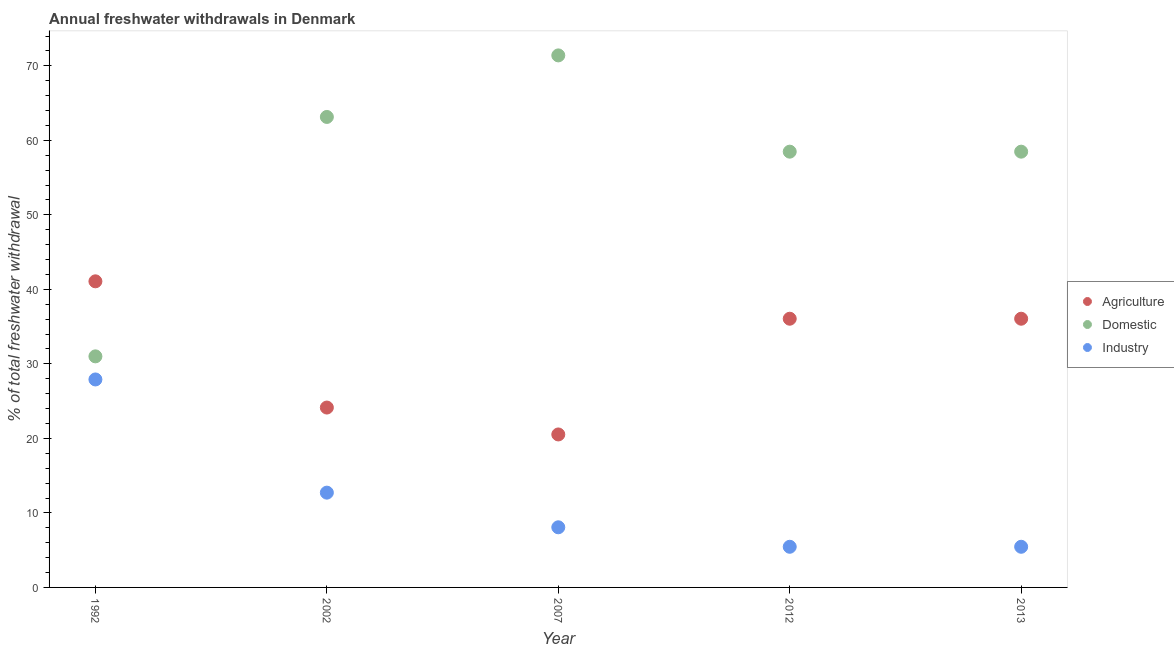What is the percentage of freshwater withdrawal for industry in 1992?
Your answer should be compact. 27.91. Across all years, what is the maximum percentage of freshwater withdrawal for domestic purposes?
Ensure brevity in your answer.  71.4. Across all years, what is the minimum percentage of freshwater withdrawal for domestic purposes?
Provide a short and direct response. 31.01. In which year was the percentage of freshwater withdrawal for agriculture maximum?
Your response must be concise. 1992. In which year was the percentage of freshwater withdrawal for industry minimum?
Ensure brevity in your answer.  2012. What is the total percentage of freshwater withdrawal for industry in the graph?
Provide a short and direct response. 59.61. What is the difference between the percentage of freshwater withdrawal for agriculture in 2002 and that in 2012?
Your answer should be compact. -11.92. What is the difference between the percentage of freshwater withdrawal for domestic purposes in 2007 and the percentage of freshwater withdrawal for agriculture in 2002?
Provide a short and direct response. 47.26. What is the average percentage of freshwater withdrawal for domestic purposes per year?
Your response must be concise. 56.5. In the year 2013, what is the difference between the percentage of freshwater withdrawal for domestic purposes and percentage of freshwater withdrawal for industry?
Keep it short and to the point. 53.02. What is the ratio of the percentage of freshwater withdrawal for agriculture in 1992 to that in 2012?
Give a very brief answer. 1.14. Is the percentage of freshwater withdrawal for industry in 2012 less than that in 2013?
Keep it short and to the point. No. Is the difference between the percentage of freshwater withdrawal for industry in 1992 and 2002 greater than the difference between the percentage of freshwater withdrawal for domestic purposes in 1992 and 2002?
Your response must be concise. Yes. What is the difference between the highest and the second highest percentage of freshwater withdrawal for agriculture?
Make the answer very short. 5.02. What is the difference between the highest and the lowest percentage of freshwater withdrawal for industry?
Your response must be concise. 22.45. Is it the case that in every year, the sum of the percentage of freshwater withdrawal for agriculture and percentage of freshwater withdrawal for domestic purposes is greater than the percentage of freshwater withdrawal for industry?
Make the answer very short. Yes. Is the percentage of freshwater withdrawal for industry strictly less than the percentage of freshwater withdrawal for domestic purposes over the years?
Ensure brevity in your answer.  Yes. How many dotlines are there?
Your response must be concise. 3. Does the graph contain any zero values?
Offer a very short reply. No. Does the graph contain grids?
Give a very brief answer. No. What is the title of the graph?
Your response must be concise. Annual freshwater withdrawals in Denmark. Does "Maunufacturing" appear as one of the legend labels in the graph?
Provide a short and direct response. No. What is the label or title of the Y-axis?
Give a very brief answer. % of total freshwater withdrawal. What is the % of total freshwater withdrawal in Agriculture in 1992?
Provide a succinct answer. 41.08. What is the % of total freshwater withdrawal of Domestic in 1992?
Give a very brief answer. 31.01. What is the % of total freshwater withdrawal of Industry in 1992?
Keep it short and to the point. 27.91. What is the % of total freshwater withdrawal in Agriculture in 2002?
Your answer should be compact. 24.14. What is the % of total freshwater withdrawal of Domestic in 2002?
Provide a short and direct response. 63.14. What is the % of total freshwater withdrawal in Industry in 2002?
Offer a terse response. 12.72. What is the % of total freshwater withdrawal of Agriculture in 2007?
Your answer should be very brief. 20.53. What is the % of total freshwater withdrawal in Domestic in 2007?
Your answer should be compact. 71.4. What is the % of total freshwater withdrawal in Industry in 2007?
Provide a succinct answer. 8.07. What is the % of total freshwater withdrawal in Agriculture in 2012?
Keep it short and to the point. 36.06. What is the % of total freshwater withdrawal in Domestic in 2012?
Offer a very short reply. 58.48. What is the % of total freshwater withdrawal in Industry in 2012?
Make the answer very short. 5.46. What is the % of total freshwater withdrawal of Agriculture in 2013?
Provide a succinct answer. 36.06. What is the % of total freshwater withdrawal in Domestic in 2013?
Keep it short and to the point. 58.48. What is the % of total freshwater withdrawal of Industry in 2013?
Your answer should be very brief. 5.46. Across all years, what is the maximum % of total freshwater withdrawal of Agriculture?
Offer a very short reply. 41.08. Across all years, what is the maximum % of total freshwater withdrawal of Domestic?
Offer a very short reply. 71.4. Across all years, what is the maximum % of total freshwater withdrawal of Industry?
Your response must be concise. 27.91. Across all years, what is the minimum % of total freshwater withdrawal in Agriculture?
Keep it short and to the point. 20.53. Across all years, what is the minimum % of total freshwater withdrawal of Domestic?
Offer a very short reply. 31.01. Across all years, what is the minimum % of total freshwater withdrawal of Industry?
Make the answer very short. 5.46. What is the total % of total freshwater withdrawal in Agriculture in the graph?
Give a very brief answer. 157.87. What is the total % of total freshwater withdrawal in Domestic in the graph?
Your answer should be compact. 282.51. What is the total % of total freshwater withdrawal in Industry in the graph?
Your answer should be very brief. 59.61. What is the difference between the % of total freshwater withdrawal of Agriculture in 1992 and that in 2002?
Your answer should be very brief. 16.94. What is the difference between the % of total freshwater withdrawal in Domestic in 1992 and that in 2002?
Ensure brevity in your answer.  -32.13. What is the difference between the % of total freshwater withdrawal in Industry in 1992 and that in 2002?
Your answer should be very brief. 15.19. What is the difference between the % of total freshwater withdrawal in Agriculture in 1992 and that in 2007?
Your answer should be very brief. 20.55. What is the difference between the % of total freshwater withdrawal of Domestic in 1992 and that in 2007?
Provide a succinct answer. -40.39. What is the difference between the % of total freshwater withdrawal in Industry in 1992 and that in 2007?
Your answer should be compact. 19.84. What is the difference between the % of total freshwater withdrawal of Agriculture in 1992 and that in 2012?
Your response must be concise. 5.02. What is the difference between the % of total freshwater withdrawal in Domestic in 1992 and that in 2012?
Offer a very short reply. -27.47. What is the difference between the % of total freshwater withdrawal in Industry in 1992 and that in 2012?
Offer a terse response. 22.45. What is the difference between the % of total freshwater withdrawal in Agriculture in 1992 and that in 2013?
Your response must be concise. 5.02. What is the difference between the % of total freshwater withdrawal in Domestic in 1992 and that in 2013?
Your answer should be compact. -27.47. What is the difference between the % of total freshwater withdrawal in Industry in 1992 and that in 2013?
Give a very brief answer. 22.45. What is the difference between the % of total freshwater withdrawal of Agriculture in 2002 and that in 2007?
Make the answer very short. 3.61. What is the difference between the % of total freshwater withdrawal of Domestic in 2002 and that in 2007?
Give a very brief answer. -8.26. What is the difference between the % of total freshwater withdrawal of Industry in 2002 and that in 2007?
Provide a succinct answer. 4.65. What is the difference between the % of total freshwater withdrawal in Agriculture in 2002 and that in 2012?
Make the answer very short. -11.92. What is the difference between the % of total freshwater withdrawal in Domestic in 2002 and that in 2012?
Make the answer very short. 4.66. What is the difference between the % of total freshwater withdrawal in Industry in 2002 and that in 2012?
Your answer should be very brief. 7.26. What is the difference between the % of total freshwater withdrawal in Agriculture in 2002 and that in 2013?
Give a very brief answer. -11.92. What is the difference between the % of total freshwater withdrawal of Domestic in 2002 and that in 2013?
Provide a succinct answer. 4.66. What is the difference between the % of total freshwater withdrawal of Industry in 2002 and that in 2013?
Make the answer very short. 7.26. What is the difference between the % of total freshwater withdrawal of Agriculture in 2007 and that in 2012?
Offer a terse response. -15.53. What is the difference between the % of total freshwater withdrawal of Domestic in 2007 and that in 2012?
Offer a terse response. 12.92. What is the difference between the % of total freshwater withdrawal in Industry in 2007 and that in 2012?
Offer a very short reply. 2.62. What is the difference between the % of total freshwater withdrawal of Agriculture in 2007 and that in 2013?
Provide a short and direct response. -15.53. What is the difference between the % of total freshwater withdrawal in Domestic in 2007 and that in 2013?
Your answer should be compact. 12.92. What is the difference between the % of total freshwater withdrawal of Industry in 2007 and that in 2013?
Provide a succinct answer. 2.62. What is the difference between the % of total freshwater withdrawal in Agriculture in 2012 and that in 2013?
Offer a very short reply. 0. What is the difference between the % of total freshwater withdrawal of Agriculture in 1992 and the % of total freshwater withdrawal of Domestic in 2002?
Provide a short and direct response. -22.06. What is the difference between the % of total freshwater withdrawal of Agriculture in 1992 and the % of total freshwater withdrawal of Industry in 2002?
Offer a very short reply. 28.36. What is the difference between the % of total freshwater withdrawal of Domestic in 1992 and the % of total freshwater withdrawal of Industry in 2002?
Provide a succinct answer. 18.29. What is the difference between the % of total freshwater withdrawal of Agriculture in 1992 and the % of total freshwater withdrawal of Domestic in 2007?
Make the answer very short. -30.32. What is the difference between the % of total freshwater withdrawal of Agriculture in 1992 and the % of total freshwater withdrawal of Industry in 2007?
Your answer should be compact. 33.01. What is the difference between the % of total freshwater withdrawal in Domestic in 1992 and the % of total freshwater withdrawal in Industry in 2007?
Your answer should be compact. 22.94. What is the difference between the % of total freshwater withdrawal of Agriculture in 1992 and the % of total freshwater withdrawal of Domestic in 2012?
Your answer should be very brief. -17.4. What is the difference between the % of total freshwater withdrawal in Agriculture in 1992 and the % of total freshwater withdrawal in Industry in 2012?
Give a very brief answer. 35.62. What is the difference between the % of total freshwater withdrawal of Domestic in 1992 and the % of total freshwater withdrawal of Industry in 2012?
Give a very brief answer. 25.55. What is the difference between the % of total freshwater withdrawal of Agriculture in 1992 and the % of total freshwater withdrawal of Domestic in 2013?
Provide a short and direct response. -17.4. What is the difference between the % of total freshwater withdrawal in Agriculture in 1992 and the % of total freshwater withdrawal in Industry in 2013?
Your answer should be compact. 35.62. What is the difference between the % of total freshwater withdrawal in Domestic in 1992 and the % of total freshwater withdrawal in Industry in 2013?
Keep it short and to the point. 25.55. What is the difference between the % of total freshwater withdrawal of Agriculture in 2002 and the % of total freshwater withdrawal of Domestic in 2007?
Ensure brevity in your answer.  -47.26. What is the difference between the % of total freshwater withdrawal of Agriculture in 2002 and the % of total freshwater withdrawal of Industry in 2007?
Provide a short and direct response. 16.07. What is the difference between the % of total freshwater withdrawal of Domestic in 2002 and the % of total freshwater withdrawal of Industry in 2007?
Provide a short and direct response. 55.07. What is the difference between the % of total freshwater withdrawal of Agriculture in 2002 and the % of total freshwater withdrawal of Domestic in 2012?
Provide a succinct answer. -34.34. What is the difference between the % of total freshwater withdrawal of Agriculture in 2002 and the % of total freshwater withdrawal of Industry in 2012?
Keep it short and to the point. 18.68. What is the difference between the % of total freshwater withdrawal of Domestic in 2002 and the % of total freshwater withdrawal of Industry in 2012?
Ensure brevity in your answer.  57.69. What is the difference between the % of total freshwater withdrawal of Agriculture in 2002 and the % of total freshwater withdrawal of Domestic in 2013?
Offer a terse response. -34.34. What is the difference between the % of total freshwater withdrawal in Agriculture in 2002 and the % of total freshwater withdrawal in Industry in 2013?
Keep it short and to the point. 18.68. What is the difference between the % of total freshwater withdrawal of Domestic in 2002 and the % of total freshwater withdrawal of Industry in 2013?
Give a very brief answer. 57.69. What is the difference between the % of total freshwater withdrawal in Agriculture in 2007 and the % of total freshwater withdrawal in Domestic in 2012?
Keep it short and to the point. -37.95. What is the difference between the % of total freshwater withdrawal of Agriculture in 2007 and the % of total freshwater withdrawal of Industry in 2012?
Offer a very short reply. 15.07. What is the difference between the % of total freshwater withdrawal of Domestic in 2007 and the % of total freshwater withdrawal of Industry in 2012?
Ensure brevity in your answer.  65.94. What is the difference between the % of total freshwater withdrawal of Agriculture in 2007 and the % of total freshwater withdrawal of Domestic in 2013?
Provide a succinct answer. -37.95. What is the difference between the % of total freshwater withdrawal of Agriculture in 2007 and the % of total freshwater withdrawal of Industry in 2013?
Keep it short and to the point. 15.07. What is the difference between the % of total freshwater withdrawal in Domestic in 2007 and the % of total freshwater withdrawal in Industry in 2013?
Offer a very short reply. 65.94. What is the difference between the % of total freshwater withdrawal of Agriculture in 2012 and the % of total freshwater withdrawal of Domestic in 2013?
Your response must be concise. -22.42. What is the difference between the % of total freshwater withdrawal in Agriculture in 2012 and the % of total freshwater withdrawal in Industry in 2013?
Give a very brief answer. 30.61. What is the difference between the % of total freshwater withdrawal in Domestic in 2012 and the % of total freshwater withdrawal in Industry in 2013?
Your response must be concise. 53.02. What is the average % of total freshwater withdrawal of Agriculture per year?
Your answer should be compact. 31.57. What is the average % of total freshwater withdrawal of Domestic per year?
Ensure brevity in your answer.  56.5. What is the average % of total freshwater withdrawal in Industry per year?
Give a very brief answer. 11.92. In the year 1992, what is the difference between the % of total freshwater withdrawal of Agriculture and % of total freshwater withdrawal of Domestic?
Keep it short and to the point. 10.07. In the year 1992, what is the difference between the % of total freshwater withdrawal in Agriculture and % of total freshwater withdrawal in Industry?
Your response must be concise. 13.17. In the year 1992, what is the difference between the % of total freshwater withdrawal in Domestic and % of total freshwater withdrawal in Industry?
Provide a succinct answer. 3.1. In the year 2002, what is the difference between the % of total freshwater withdrawal of Agriculture and % of total freshwater withdrawal of Domestic?
Your answer should be very brief. -39. In the year 2002, what is the difference between the % of total freshwater withdrawal in Agriculture and % of total freshwater withdrawal in Industry?
Offer a very short reply. 11.42. In the year 2002, what is the difference between the % of total freshwater withdrawal in Domestic and % of total freshwater withdrawal in Industry?
Keep it short and to the point. 50.42. In the year 2007, what is the difference between the % of total freshwater withdrawal in Agriculture and % of total freshwater withdrawal in Domestic?
Your answer should be compact. -50.87. In the year 2007, what is the difference between the % of total freshwater withdrawal of Agriculture and % of total freshwater withdrawal of Industry?
Your response must be concise. 12.46. In the year 2007, what is the difference between the % of total freshwater withdrawal of Domestic and % of total freshwater withdrawal of Industry?
Keep it short and to the point. 63.33. In the year 2012, what is the difference between the % of total freshwater withdrawal in Agriculture and % of total freshwater withdrawal in Domestic?
Give a very brief answer. -22.42. In the year 2012, what is the difference between the % of total freshwater withdrawal of Agriculture and % of total freshwater withdrawal of Industry?
Provide a short and direct response. 30.61. In the year 2012, what is the difference between the % of total freshwater withdrawal in Domestic and % of total freshwater withdrawal in Industry?
Provide a succinct answer. 53.02. In the year 2013, what is the difference between the % of total freshwater withdrawal in Agriculture and % of total freshwater withdrawal in Domestic?
Keep it short and to the point. -22.42. In the year 2013, what is the difference between the % of total freshwater withdrawal in Agriculture and % of total freshwater withdrawal in Industry?
Ensure brevity in your answer.  30.61. In the year 2013, what is the difference between the % of total freshwater withdrawal of Domestic and % of total freshwater withdrawal of Industry?
Offer a very short reply. 53.02. What is the ratio of the % of total freshwater withdrawal of Agriculture in 1992 to that in 2002?
Offer a very short reply. 1.7. What is the ratio of the % of total freshwater withdrawal of Domestic in 1992 to that in 2002?
Your response must be concise. 0.49. What is the ratio of the % of total freshwater withdrawal in Industry in 1992 to that in 2002?
Your answer should be compact. 2.19. What is the ratio of the % of total freshwater withdrawal in Agriculture in 1992 to that in 2007?
Provide a succinct answer. 2. What is the ratio of the % of total freshwater withdrawal of Domestic in 1992 to that in 2007?
Make the answer very short. 0.43. What is the ratio of the % of total freshwater withdrawal in Industry in 1992 to that in 2007?
Provide a short and direct response. 3.46. What is the ratio of the % of total freshwater withdrawal in Agriculture in 1992 to that in 2012?
Your answer should be very brief. 1.14. What is the ratio of the % of total freshwater withdrawal in Domestic in 1992 to that in 2012?
Keep it short and to the point. 0.53. What is the ratio of the % of total freshwater withdrawal in Industry in 1992 to that in 2012?
Keep it short and to the point. 5.12. What is the ratio of the % of total freshwater withdrawal in Agriculture in 1992 to that in 2013?
Provide a short and direct response. 1.14. What is the ratio of the % of total freshwater withdrawal in Domestic in 1992 to that in 2013?
Your response must be concise. 0.53. What is the ratio of the % of total freshwater withdrawal of Industry in 1992 to that in 2013?
Provide a succinct answer. 5.12. What is the ratio of the % of total freshwater withdrawal in Agriculture in 2002 to that in 2007?
Provide a succinct answer. 1.18. What is the ratio of the % of total freshwater withdrawal of Domestic in 2002 to that in 2007?
Your response must be concise. 0.88. What is the ratio of the % of total freshwater withdrawal of Industry in 2002 to that in 2007?
Provide a succinct answer. 1.58. What is the ratio of the % of total freshwater withdrawal of Agriculture in 2002 to that in 2012?
Provide a succinct answer. 0.67. What is the ratio of the % of total freshwater withdrawal in Domestic in 2002 to that in 2012?
Your answer should be compact. 1.08. What is the ratio of the % of total freshwater withdrawal of Industry in 2002 to that in 2012?
Offer a terse response. 2.33. What is the ratio of the % of total freshwater withdrawal of Agriculture in 2002 to that in 2013?
Your response must be concise. 0.67. What is the ratio of the % of total freshwater withdrawal of Domestic in 2002 to that in 2013?
Provide a short and direct response. 1.08. What is the ratio of the % of total freshwater withdrawal of Industry in 2002 to that in 2013?
Your answer should be very brief. 2.33. What is the ratio of the % of total freshwater withdrawal of Agriculture in 2007 to that in 2012?
Keep it short and to the point. 0.57. What is the ratio of the % of total freshwater withdrawal of Domestic in 2007 to that in 2012?
Provide a succinct answer. 1.22. What is the ratio of the % of total freshwater withdrawal of Industry in 2007 to that in 2012?
Your answer should be compact. 1.48. What is the ratio of the % of total freshwater withdrawal of Agriculture in 2007 to that in 2013?
Provide a short and direct response. 0.57. What is the ratio of the % of total freshwater withdrawal in Domestic in 2007 to that in 2013?
Give a very brief answer. 1.22. What is the ratio of the % of total freshwater withdrawal in Industry in 2007 to that in 2013?
Your answer should be compact. 1.48. What is the ratio of the % of total freshwater withdrawal of Agriculture in 2012 to that in 2013?
Your answer should be compact. 1. What is the ratio of the % of total freshwater withdrawal in Industry in 2012 to that in 2013?
Make the answer very short. 1. What is the difference between the highest and the second highest % of total freshwater withdrawal in Agriculture?
Your response must be concise. 5.02. What is the difference between the highest and the second highest % of total freshwater withdrawal of Domestic?
Make the answer very short. 8.26. What is the difference between the highest and the second highest % of total freshwater withdrawal of Industry?
Make the answer very short. 15.19. What is the difference between the highest and the lowest % of total freshwater withdrawal of Agriculture?
Provide a short and direct response. 20.55. What is the difference between the highest and the lowest % of total freshwater withdrawal of Domestic?
Offer a terse response. 40.39. What is the difference between the highest and the lowest % of total freshwater withdrawal in Industry?
Make the answer very short. 22.45. 